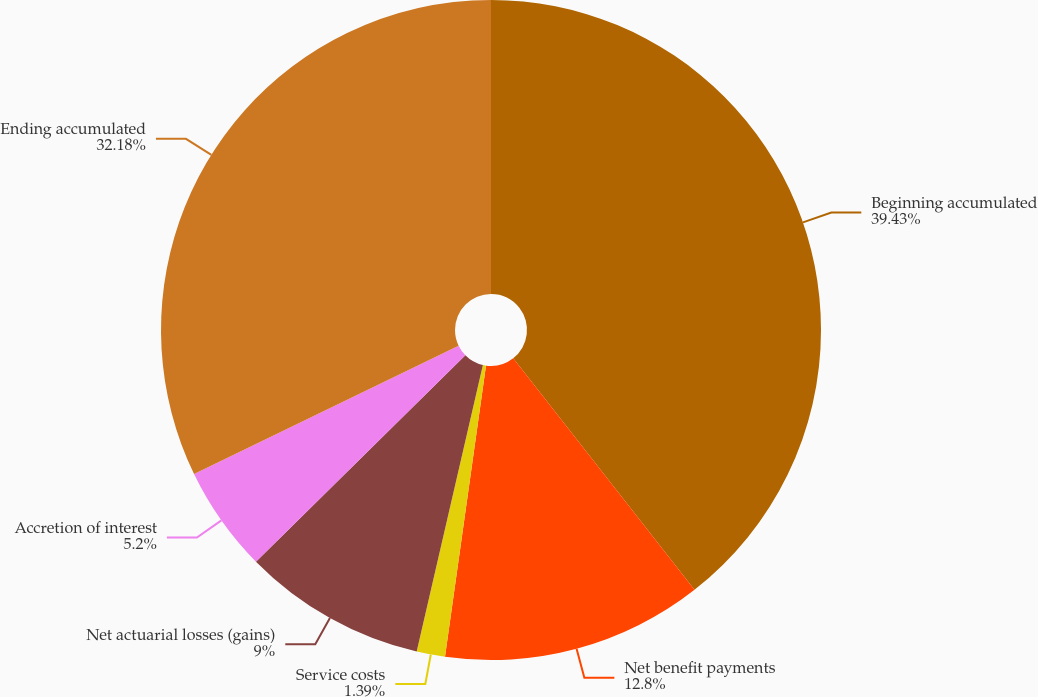<chart> <loc_0><loc_0><loc_500><loc_500><pie_chart><fcel>Beginning accumulated<fcel>Net benefit payments<fcel>Service costs<fcel>Net actuarial losses (gains)<fcel>Accretion of interest<fcel>Ending accumulated<nl><fcel>39.42%<fcel>12.8%<fcel>1.39%<fcel>9.0%<fcel>5.2%<fcel>32.18%<nl></chart> 